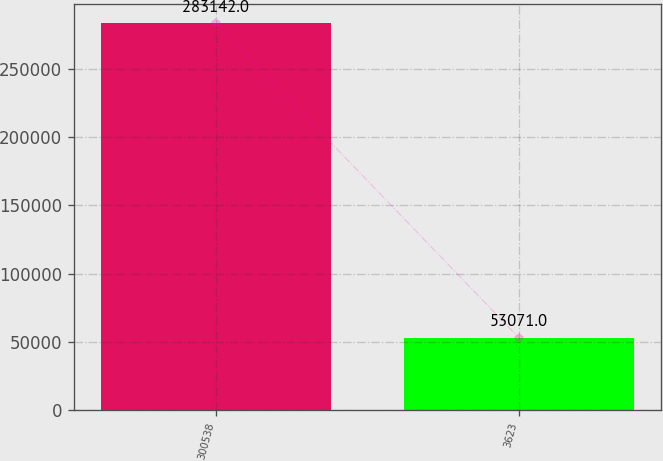Convert chart. <chart><loc_0><loc_0><loc_500><loc_500><bar_chart><fcel>300538<fcel>3623<nl><fcel>283142<fcel>53071<nl></chart> 